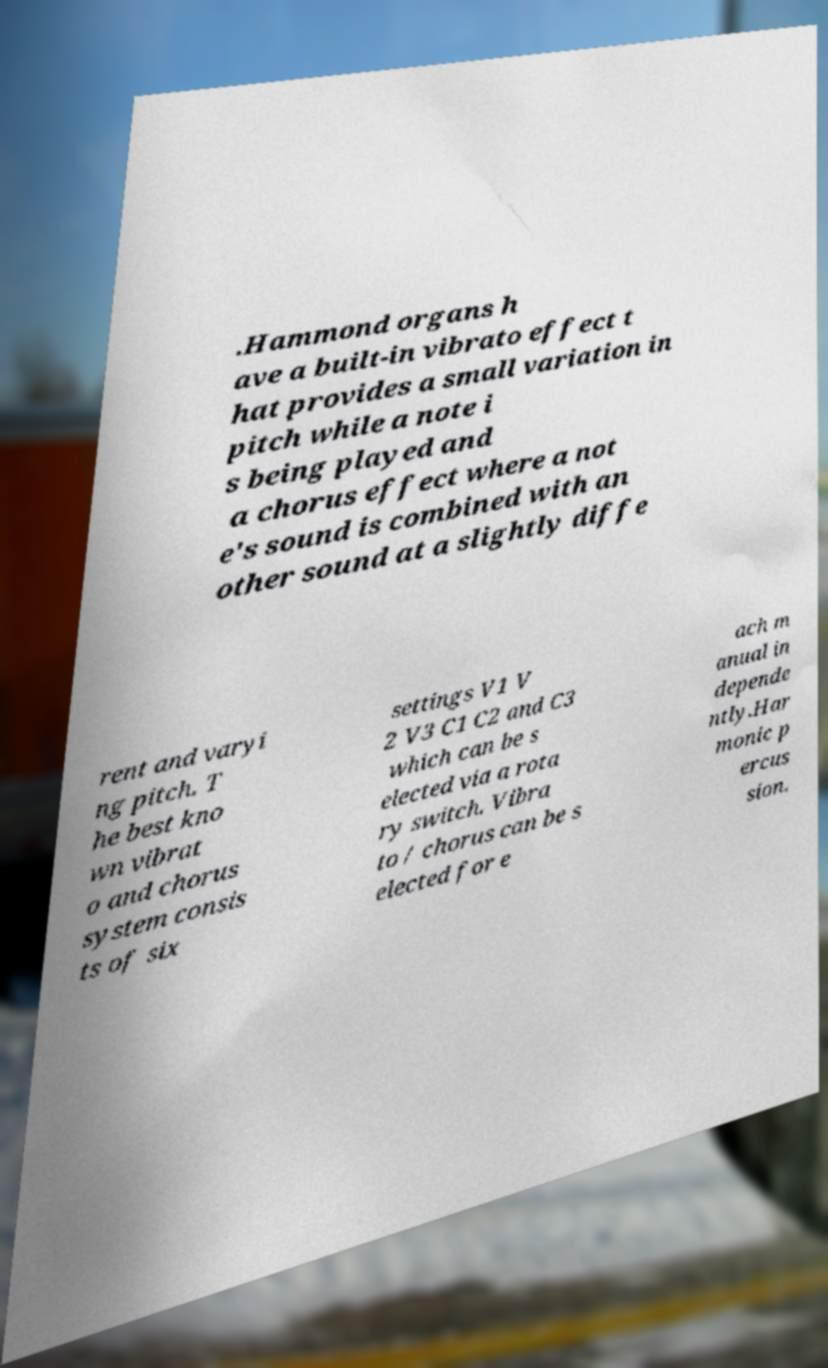Could you extract and type out the text from this image? .Hammond organs h ave a built-in vibrato effect t hat provides a small variation in pitch while a note i s being played and a chorus effect where a not e's sound is combined with an other sound at a slightly diffe rent and varyi ng pitch. T he best kno wn vibrat o and chorus system consis ts of six settings V1 V 2 V3 C1 C2 and C3 which can be s elected via a rota ry switch. Vibra to / chorus can be s elected for e ach m anual in depende ntly.Har monic p ercus sion. 